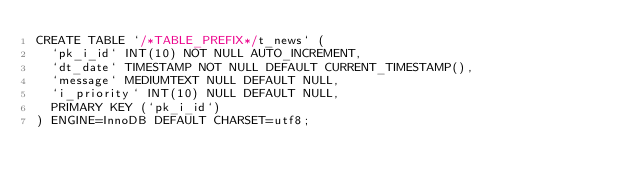Convert code to text. <code><loc_0><loc_0><loc_500><loc_500><_SQL_>CREATE TABLE `/*TABLE_PREFIX*/t_news` (
  `pk_i_id` INT(10) NOT NULL AUTO_INCREMENT, 
  `dt_date` TIMESTAMP NOT NULL DEFAULT CURRENT_TIMESTAMP(), 
  `message` MEDIUMTEXT NULL DEFAULT NULL,
  `i_priority` INT(10) NULL DEFAULT NULL,
  PRIMARY KEY (`pk_i_id`)
) ENGINE=InnoDB DEFAULT CHARSET=utf8;
</code> 